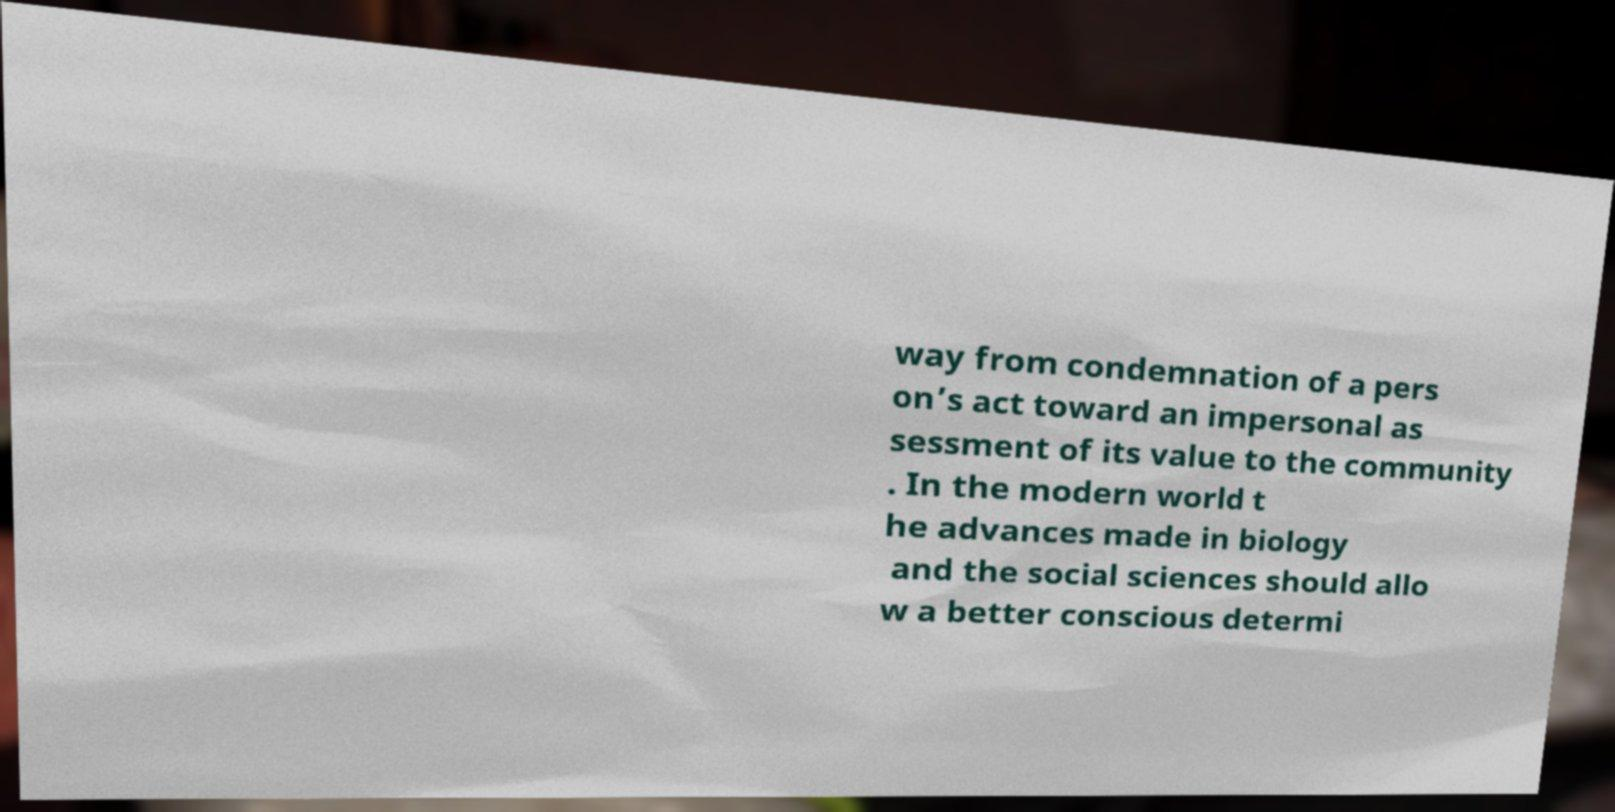For documentation purposes, I need the text within this image transcribed. Could you provide that? way from condemnation of a pers on’s act toward an impersonal as sessment of its value to the community . In the modern world t he advances made in biology and the social sciences should allo w a better conscious determi 